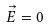Convert formula to latex. <formula><loc_0><loc_0><loc_500><loc_500>\vec { E } = 0</formula> 